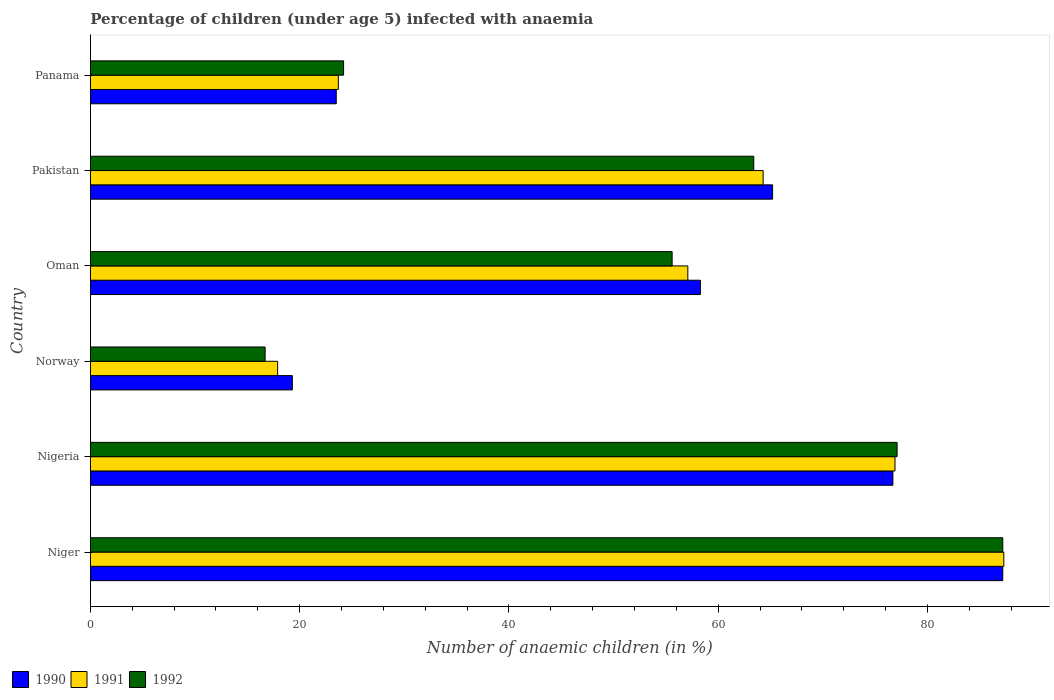How many different coloured bars are there?
Offer a terse response. 3. Are the number of bars per tick equal to the number of legend labels?
Your answer should be very brief. Yes. Are the number of bars on each tick of the Y-axis equal?
Ensure brevity in your answer.  Yes. How many bars are there on the 4th tick from the bottom?
Offer a very short reply. 3. What is the label of the 3rd group of bars from the top?
Keep it short and to the point. Oman. In how many cases, is the number of bars for a given country not equal to the number of legend labels?
Keep it short and to the point. 0. What is the percentage of children infected with anaemia in in 1990 in Norway?
Offer a terse response. 19.3. Across all countries, what is the maximum percentage of children infected with anaemia in in 1992?
Your answer should be compact. 87.2. Across all countries, what is the minimum percentage of children infected with anaemia in in 1992?
Give a very brief answer. 16.7. In which country was the percentage of children infected with anaemia in in 1991 maximum?
Keep it short and to the point. Niger. What is the total percentage of children infected with anaemia in in 1992 in the graph?
Offer a terse response. 324.2. What is the difference between the percentage of children infected with anaemia in in 1991 in Nigeria and that in Norway?
Your answer should be very brief. 59. What is the difference between the percentage of children infected with anaemia in in 1990 in Panama and the percentage of children infected with anaemia in in 1992 in Niger?
Your answer should be compact. -63.7. What is the average percentage of children infected with anaemia in in 1991 per country?
Your answer should be compact. 54.53. What is the difference between the percentage of children infected with anaemia in in 1992 and percentage of children infected with anaemia in in 1991 in Niger?
Make the answer very short. -0.1. What is the ratio of the percentage of children infected with anaemia in in 1990 in Oman to that in Pakistan?
Offer a terse response. 0.89. Is the percentage of children infected with anaemia in in 1991 in Niger less than that in Panama?
Give a very brief answer. No. Is the difference between the percentage of children infected with anaemia in in 1992 in Niger and Oman greater than the difference between the percentage of children infected with anaemia in in 1991 in Niger and Oman?
Offer a very short reply. Yes. What is the difference between the highest and the lowest percentage of children infected with anaemia in in 1990?
Ensure brevity in your answer.  67.9. In how many countries, is the percentage of children infected with anaemia in in 1990 greater than the average percentage of children infected with anaemia in in 1990 taken over all countries?
Offer a very short reply. 4. Is the sum of the percentage of children infected with anaemia in in 1990 in Nigeria and Panama greater than the maximum percentage of children infected with anaemia in in 1992 across all countries?
Provide a succinct answer. Yes. What does the 1st bar from the top in Oman represents?
Offer a terse response. 1992. Is it the case that in every country, the sum of the percentage of children infected with anaemia in in 1992 and percentage of children infected with anaemia in in 1990 is greater than the percentage of children infected with anaemia in in 1991?
Provide a succinct answer. Yes. How many bars are there?
Keep it short and to the point. 18. Are all the bars in the graph horizontal?
Provide a short and direct response. Yes. How many legend labels are there?
Make the answer very short. 3. What is the title of the graph?
Provide a succinct answer. Percentage of children (under age 5) infected with anaemia. Does "1977" appear as one of the legend labels in the graph?
Make the answer very short. No. What is the label or title of the X-axis?
Offer a very short reply. Number of anaemic children (in %). What is the label or title of the Y-axis?
Keep it short and to the point. Country. What is the Number of anaemic children (in %) in 1990 in Niger?
Offer a very short reply. 87.2. What is the Number of anaemic children (in %) in 1991 in Niger?
Make the answer very short. 87.3. What is the Number of anaemic children (in %) of 1992 in Niger?
Your answer should be compact. 87.2. What is the Number of anaemic children (in %) of 1990 in Nigeria?
Offer a terse response. 76.7. What is the Number of anaemic children (in %) of 1991 in Nigeria?
Offer a terse response. 76.9. What is the Number of anaemic children (in %) of 1992 in Nigeria?
Keep it short and to the point. 77.1. What is the Number of anaemic children (in %) in 1990 in Norway?
Ensure brevity in your answer.  19.3. What is the Number of anaemic children (in %) of 1992 in Norway?
Offer a terse response. 16.7. What is the Number of anaemic children (in %) of 1990 in Oman?
Your answer should be compact. 58.3. What is the Number of anaemic children (in %) in 1991 in Oman?
Provide a short and direct response. 57.1. What is the Number of anaemic children (in %) in 1992 in Oman?
Make the answer very short. 55.6. What is the Number of anaemic children (in %) in 1990 in Pakistan?
Offer a terse response. 65.2. What is the Number of anaemic children (in %) in 1991 in Pakistan?
Your answer should be compact. 64.3. What is the Number of anaemic children (in %) in 1992 in Pakistan?
Keep it short and to the point. 63.4. What is the Number of anaemic children (in %) of 1990 in Panama?
Your answer should be very brief. 23.5. What is the Number of anaemic children (in %) in 1991 in Panama?
Provide a succinct answer. 23.7. What is the Number of anaemic children (in %) in 1992 in Panama?
Offer a very short reply. 24.2. Across all countries, what is the maximum Number of anaemic children (in %) in 1990?
Provide a short and direct response. 87.2. Across all countries, what is the maximum Number of anaemic children (in %) of 1991?
Your answer should be compact. 87.3. Across all countries, what is the maximum Number of anaemic children (in %) in 1992?
Provide a short and direct response. 87.2. Across all countries, what is the minimum Number of anaemic children (in %) in 1990?
Provide a succinct answer. 19.3. Across all countries, what is the minimum Number of anaemic children (in %) of 1991?
Provide a succinct answer. 17.9. What is the total Number of anaemic children (in %) of 1990 in the graph?
Provide a short and direct response. 330.2. What is the total Number of anaemic children (in %) of 1991 in the graph?
Provide a succinct answer. 327.2. What is the total Number of anaemic children (in %) of 1992 in the graph?
Keep it short and to the point. 324.2. What is the difference between the Number of anaemic children (in %) of 1990 in Niger and that in Nigeria?
Offer a very short reply. 10.5. What is the difference between the Number of anaemic children (in %) in 1991 in Niger and that in Nigeria?
Offer a very short reply. 10.4. What is the difference between the Number of anaemic children (in %) in 1992 in Niger and that in Nigeria?
Offer a very short reply. 10.1. What is the difference between the Number of anaemic children (in %) of 1990 in Niger and that in Norway?
Give a very brief answer. 67.9. What is the difference between the Number of anaemic children (in %) of 1991 in Niger and that in Norway?
Your answer should be very brief. 69.4. What is the difference between the Number of anaemic children (in %) of 1992 in Niger and that in Norway?
Your answer should be very brief. 70.5. What is the difference between the Number of anaemic children (in %) of 1990 in Niger and that in Oman?
Your answer should be compact. 28.9. What is the difference between the Number of anaemic children (in %) in 1991 in Niger and that in Oman?
Offer a terse response. 30.2. What is the difference between the Number of anaemic children (in %) of 1992 in Niger and that in Oman?
Your answer should be very brief. 31.6. What is the difference between the Number of anaemic children (in %) in 1990 in Niger and that in Pakistan?
Give a very brief answer. 22. What is the difference between the Number of anaemic children (in %) in 1992 in Niger and that in Pakistan?
Make the answer very short. 23.8. What is the difference between the Number of anaemic children (in %) of 1990 in Niger and that in Panama?
Offer a terse response. 63.7. What is the difference between the Number of anaemic children (in %) of 1991 in Niger and that in Panama?
Your response must be concise. 63.6. What is the difference between the Number of anaemic children (in %) in 1992 in Niger and that in Panama?
Make the answer very short. 63. What is the difference between the Number of anaemic children (in %) of 1990 in Nigeria and that in Norway?
Your answer should be compact. 57.4. What is the difference between the Number of anaemic children (in %) of 1992 in Nigeria and that in Norway?
Provide a succinct answer. 60.4. What is the difference between the Number of anaemic children (in %) in 1991 in Nigeria and that in Oman?
Keep it short and to the point. 19.8. What is the difference between the Number of anaemic children (in %) in 1990 in Nigeria and that in Pakistan?
Provide a succinct answer. 11.5. What is the difference between the Number of anaemic children (in %) of 1992 in Nigeria and that in Pakistan?
Your answer should be compact. 13.7. What is the difference between the Number of anaemic children (in %) in 1990 in Nigeria and that in Panama?
Ensure brevity in your answer.  53.2. What is the difference between the Number of anaemic children (in %) of 1991 in Nigeria and that in Panama?
Your answer should be very brief. 53.2. What is the difference between the Number of anaemic children (in %) of 1992 in Nigeria and that in Panama?
Offer a very short reply. 52.9. What is the difference between the Number of anaemic children (in %) of 1990 in Norway and that in Oman?
Your answer should be compact. -39. What is the difference between the Number of anaemic children (in %) of 1991 in Norway and that in Oman?
Offer a terse response. -39.2. What is the difference between the Number of anaemic children (in %) in 1992 in Norway and that in Oman?
Make the answer very short. -38.9. What is the difference between the Number of anaemic children (in %) in 1990 in Norway and that in Pakistan?
Make the answer very short. -45.9. What is the difference between the Number of anaemic children (in %) in 1991 in Norway and that in Pakistan?
Your answer should be compact. -46.4. What is the difference between the Number of anaemic children (in %) of 1992 in Norway and that in Pakistan?
Ensure brevity in your answer.  -46.7. What is the difference between the Number of anaemic children (in %) in 1990 in Norway and that in Panama?
Offer a terse response. -4.2. What is the difference between the Number of anaemic children (in %) of 1991 in Norway and that in Panama?
Provide a short and direct response. -5.8. What is the difference between the Number of anaemic children (in %) of 1992 in Norway and that in Panama?
Ensure brevity in your answer.  -7.5. What is the difference between the Number of anaemic children (in %) of 1991 in Oman and that in Pakistan?
Give a very brief answer. -7.2. What is the difference between the Number of anaemic children (in %) in 1992 in Oman and that in Pakistan?
Your answer should be very brief. -7.8. What is the difference between the Number of anaemic children (in %) of 1990 in Oman and that in Panama?
Offer a very short reply. 34.8. What is the difference between the Number of anaemic children (in %) of 1991 in Oman and that in Panama?
Provide a succinct answer. 33.4. What is the difference between the Number of anaemic children (in %) in 1992 in Oman and that in Panama?
Your answer should be very brief. 31.4. What is the difference between the Number of anaemic children (in %) of 1990 in Pakistan and that in Panama?
Offer a terse response. 41.7. What is the difference between the Number of anaemic children (in %) of 1991 in Pakistan and that in Panama?
Your answer should be very brief. 40.6. What is the difference between the Number of anaemic children (in %) in 1992 in Pakistan and that in Panama?
Make the answer very short. 39.2. What is the difference between the Number of anaemic children (in %) of 1990 in Niger and the Number of anaemic children (in %) of 1991 in Nigeria?
Your answer should be compact. 10.3. What is the difference between the Number of anaemic children (in %) in 1991 in Niger and the Number of anaemic children (in %) in 1992 in Nigeria?
Keep it short and to the point. 10.2. What is the difference between the Number of anaemic children (in %) in 1990 in Niger and the Number of anaemic children (in %) in 1991 in Norway?
Offer a very short reply. 69.3. What is the difference between the Number of anaemic children (in %) in 1990 in Niger and the Number of anaemic children (in %) in 1992 in Norway?
Offer a very short reply. 70.5. What is the difference between the Number of anaemic children (in %) of 1991 in Niger and the Number of anaemic children (in %) of 1992 in Norway?
Ensure brevity in your answer.  70.6. What is the difference between the Number of anaemic children (in %) in 1990 in Niger and the Number of anaemic children (in %) in 1991 in Oman?
Make the answer very short. 30.1. What is the difference between the Number of anaemic children (in %) of 1990 in Niger and the Number of anaemic children (in %) of 1992 in Oman?
Provide a succinct answer. 31.6. What is the difference between the Number of anaemic children (in %) of 1991 in Niger and the Number of anaemic children (in %) of 1992 in Oman?
Offer a very short reply. 31.7. What is the difference between the Number of anaemic children (in %) in 1990 in Niger and the Number of anaemic children (in %) in 1991 in Pakistan?
Ensure brevity in your answer.  22.9. What is the difference between the Number of anaemic children (in %) in 1990 in Niger and the Number of anaemic children (in %) in 1992 in Pakistan?
Keep it short and to the point. 23.8. What is the difference between the Number of anaemic children (in %) in 1991 in Niger and the Number of anaemic children (in %) in 1992 in Pakistan?
Your response must be concise. 23.9. What is the difference between the Number of anaemic children (in %) of 1990 in Niger and the Number of anaemic children (in %) of 1991 in Panama?
Keep it short and to the point. 63.5. What is the difference between the Number of anaemic children (in %) in 1991 in Niger and the Number of anaemic children (in %) in 1992 in Panama?
Ensure brevity in your answer.  63.1. What is the difference between the Number of anaemic children (in %) of 1990 in Nigeria and the Number of anaemic children (in %) of 1991 in Norway?
Keep it short and to the point. 58.8. What is the difference between the Number of anaemic children (in %) in 1990 in Nigeria and the Number of anaemic children (in %) in 1992 in Norway?
Your answer should be compact. 60. What is the difference between the Number of anaemic children (in %) of 1991 in Nigeria and the Number of anaemic children (in %) of 1992 in Norway?
Provide a succinct answer. 60.2. What is the difference between the Number of anaemic children (in %) in 1990 in Nigeria and the Number of anaemic children (in %) in 1991 in Oman?
Your answer should be compact. 19.6. What is the difference between the Number of anaemic children (in %) of 1990 in Nigeria and the Number of anaemic children (in %) of 1992 in Oman?
Keep it short and to the point. 21.1. What is the difference between the Number of anaemic children (in %) of 1991 in Nigeria and the Number of anaemic children (in %) of 1992 in Oman?
Provide a succinct answer. 21.3. What is the difference between the Number of anaemic children (in %) in 1990 in Nigeria and the Number of anaemic children (in %) in 1992 in Pakistan?
Ensure brevity in your answer.  13.3. What is the difference between the Number of anaemic children (in %) in 1991 in Nigeria and the Number of anaemic children (in %) in 1992 in Pakistan?
Give a very brief answer. 13.5. What is the difference between the Number of anaemic children (in %) in 1990 in Nigeria and the Number of anaemic children (in %) in 1992 in Panama?
Offer a very short reply. 52.5. What is the difference between the Number of anaemic children (in %) in 1991 in Nigeria and the Number of anaemic children (in %) in 1992 in Panama?
Keep it short and to the point. 52.7. What is the difference between the Number of anaemic children (in %) in 1990 in Norway and the Number of anaemic children (in %) in 1991 in Oman?
Give a very brief answer. -37.8. What is the difference between the Number of anaemic children (in %) in 1990 in Norway and the Number of anaemic children (in %) in 1992 in Oman?
Provide a short and direct response. -36.3. What is the difference between the Number of anaemic children (in %) of 1991 in Norway and the Number of anaemic children (in %) of 1992 in Oman?
Your response must be concise. -37.7. What is the difference between the Number of anaemic children (in %) in 1990 in Norway and the Number of anaemic children (in %) in 1991 in Pakistan?
Your response must be concise. -45. What is the difference between the Number of anaemic children (in %) in 1990 in Norway and the Number of anaemic children (in %) in 1992 in Pakistan?
Make the answer very short. -44.1. What is the difference between the Number of anaemic children (in %) in 1991 in Norway and the Number of anaemic children (in %) in 1992 in Pakistan?
Offer a very short reply. -45.5. What is the difference between the Number of anaemic children (in %) in 1990 in Norway and the Number of anaemic children (in %) in 1992 in Panama?
Provide a succinct answer. -4.9. What is the difference between the Number of anaemic children (in %) of 1991 in Norway and the Number of anaemic children (in %) of 1992 in Panama?
Make the answer very short. -6.3. What is the difference between the Number of anaemic children (in %) of 1990 in Oman and the Number of anaemic children (in %) of 1991 in Pakistan?
Your answer should be very brief. -6. What is the difference between the Number of anaemic children (in %) of 1990 in Oman and the Number of anaemic children (in %) of 1992 in Pakistan?
Offer a terse response. -5.1. What is the difference between the Number of anaemic children (in %) in 1990 in Oman and the Number of anaemic children (in %) in 1991 in Panama?
Ensure brevity in your answer.  34.6. What is the difference between the Number of anaemic children (in %) of 1990 in Oman and the Number of anaemic children (in %) of 1992 in Panama?
Make the answer very short. 34.1. What is the difference between the Number of anaemic children (in %) of 1991 in Oman and the Number of anaemic children (in %) of 1992 in Panama?
Your answer should be compact. 32.9. What is the difference between the Number of anaemic children (in %) in 1990 in Pakistan and the Number of anaemic children (in %) in 1991 in Panama?
Make the answer very short. 41.5. What is the difference between the Number of anaemic children (in %) in 1990 in Pakistan and the Number of anaemic children (in %) in 1992 in Panama?
Keep it short and to the point. 41. What is the difference between the Number of anaemic children (in %) in 1991 in Pakistan and the Number of anaemic children (in %) in 1992 in Panama?
Your answer should be very brief. 40.1. What is the average Number of anaemic children (in %) in 1990 per country?
Make the answer very short. 55.03. What is the average Number of anaemic children (in %) in 1991 per country?
Offer a terse response. 54.53. What is the average Number of anaemic children (in %) of 1992 per country?
Keep it short and to the point. 54.03. What is the difference between the Number of anaemic children (in %) in 1990 and Number of anaemic children (in %) in 1991 in Nigeria?
Your response must be concise. -0.2. What is the difference between the Number of anaemic children (in %) in 1990 and Number of anaemic children (in %) in 1992 in Nigeria?
Your answer should be very brief. -0.4. What is the difference between the Number of anaemic children (in %) in 1991 and Number of anaemic children (in %) in 1992 in Nigeria?
Your answer should be very brief. -0.2. What is the difference between the Number of anaemic children (in %) in 1990 and Number of anaemic children (in %) in 1991 in Norway?
Your response must be concise. 1.4. What is the difference between the Number of anaemic children (in %) in 1990 and Number of anaemic children (in %) in 1992 in Norway?
Give a very brief answer. 2.6. What is the difference between the Number of anaemic children (in %) of 1990 and Number of anaemic children (in %) of 1991 in Oman?
Make the answer very short. 1.2. What is the difference between the Number of anaemic children (in %) of 1990 and Number of anaemic children (in %) of 1992 in Oman?
Provide a short and direct response. 2.7. What is the difference between the Number of anaemic children (in %) of 1991 and Number of anaemic children (in %) of 1992 in Oman?
Your response must be concise. 1.5. What is the difference between the Number of anaemic children (in %) in 1991 and Number of anaemic children (in %) in 1992 in Pakistan?
Ensure brevity in your answer.  0.9. What is the difference between the Number of anaemic children (in %) of 1990 and Number of anaemic children (in %) of 1991 in Panama?
Offer a terse response. -0.2. What is the ratio of the Number of anaemic children (in %) of 1990 in Niger to that in Nigeria?
Give a very brief answer. 1.14. What is the ratio of the Number of anaemic children (in %) in 1991 in Niger to that in Nigeria?
Your answer should be very brief. 1.14. What is the ratio of the Number of anaemic children (in %) in 1992 in Niger to that in Nigeria?
Give a very brief answer. 1.13. What is the ratio of the Number of anaemic children (in %) of 1990 in Niger to that in Norway?
Provide a succinct answer. 4.52. What is the ratio of the Number of anaemic children (in %) in 1991 in Niger to that in Norway?
Offer a terse response. 4.88. What is the ratio of the Number of anaemic children (in %) in 1992 in Niger to that in Norway?
Your response must be concise. 5.22. What is the ratio of the Number of anaemic children (in %) in 1990 in Niger to that in Oman?
Your answer should be compact. 1.5. What is the ratio of the Number of anaemic children (in %) in 1991 in Niger to that in Oman?
Give a very brief answer. 1.53. What is the ratio of the Number of anaemic children (in %) in 1992 in Niger to that in Oman?
Make the answer very short. 1.57. What is the ratio of the Number of anaemic children (in %) of 1990 in Niger to that in Pakistan?
Ensure brevity in your answer.  1.34. What is the ratio of the Number of anaemic children (in %) of 1991 in Niger to that in Pakistan?
Your response must be concise. 1.36. What is the ratio of the Number of anaemic children (in %) in 1992 in Niger to that in Pakistan?
Provide a short and direct response. 1.38. What is the ratio of the Number of anaemic children (in %) of 1990 in Niger to that in Panama?
Your response must be concise. 3.71. What is the ratio of the Number of anaemic children (in %) of 1991 in Niger to that in Panama?
Make the answer very short. 3.68. What is the ratio of the Number of anaemic children (in %) in 1992 in Niger to that in Panama?
Your answer should be very brief. 3.6. What is the ratio of the Number of anaemic children (in %) in 1990 in Nigeria to that in Norway?
Provide a succinct answer. 3.97. What is the ratio of the Number of anaemic children (in %) in 1991 in Nigeria to that in Norway?
Provide a succinct answer. 4.3. What is the ratio of the Number of anaemic children (in %) in 1992 in Nigeria to that in Norway?
Provide a succinct answer. 4.62. What is the ratio of the Number of anaemic children (in %) of 1990 in Nigeria to that in Oman?
Ensure brevity in your answer.  1.32. What is the ratio of the Number of anaemic children (in %) of 1991 in Nigeria to that in Oman?
Provide a short and direct response. 1.35. What is the ratio of the Number of anaemic children (in %) in 1992 in Nigeria to that in Oman?
Your response must be concise. 1.39. What is the ratio of the Number of anaemic children (in %) in 1990 in Nigeria to that in Pakistan?
Your response must be concise. 1.18. What is the ratio of the Number of anaemic children (in %) in 1991 in Nigeria to that in Pakistan?
Provide a short and direct response. 1.2. What is the ratio of the Number of anaemic children (in %) in 1992 in Nigeria to that in Pakistan?
Keep it short and to the point. 1.22. What is the ratio of the Number of anaemic children (in %) of 1990 in Nigeria to that in Panama?
Your answer should be very brief. 3.26. What is the ratio of the Number of anaemic children (in %) of 1991 in Nigeria to that in Panama?
Keep it short and to the point. 3.24. What is the ratio of the Number of anaemic children (in %) in 1992 in Nigeria to that in Panama?
Provide a succinct answer. 3.19. What is the ratio of the Number of anaemic children (in %) in 1990 in Norway to that in Oman?
Keep it short and to the point. 0.33. What is the ratio of the Number of anaemic children (in %) in 1991 in Norway to that in Oman?
Offer a terse response. 0.31. What is the ratio of the Number of anaemic children (in %) of 1992 in Norway to that in Oman?
Provide a succinct answer. 0.3. What is the ratio of the Number of anaemic children (in %) of 1990 in Norway to that in Pakistan?
Offer a terse response. 0.3. What is the ratio of the Number of anaemic children (in %) of 1991 in Norway to that in Pakistan?
Give a very brief answer. 0.28. What is the ratio of the Number of anaemic children (in %) in 1992 in Norway to that in Pakistan?
Make the answer very short. 0.26. What is the ratio of the Number of anaemic children (in %) of 1990 in Norway to that in Panama?
Offer a very short reply. 0.82. What is the ratio of the Number of anaemic children (in %) of 1991 in Norway to that in Panama?
Your response must be concise. 0.76. What is the ratio of the Number of anaemic children (in %) in 1992 in Norway to that in Panama?
Your answer should be compact. 0.69. What is the ratio of the Number of anaemic children (in %) of 1990 in Oman to that in Pakistan?
Make the answer very short. 0.89. What is the ratio of the Number of anaemic children (in %) of 1991 in Oman to that in Pakistan?
Your answer should be compact. 0.89. What is the ratio of the Number of anaemic children (in %) of 1992 in Oman to that in Pakistan?
Make the answer very short. 0.88. What is the ratio of the Number of anaemic children (in %) in 1990 in Oman to that in Panama?
Offer a terse response. 2.48. What is the ratio of the Number of anaemic children (in %) in 1991 in Oman to that in Panama?
Your response must be concise. 2.41. What is the ratio of the Number of anaemic children (in %) in 1992 in Oman to that in Panama?
Make the answer very short. 2.3. What is the ratio of the Number of anaemic children (in %) of 1990 in Pakistan to that in Panama?
Offer a very short reply. 2.77. What is the ratio of the Number of anaemic children (in %) of 1991 in Pakistan to that in Panama?
Ensure brevity in your answer.  2.71. What is the ratio of the Number of anaemic children (in %) in 1992 in Pakistan to that in Panama?
Your response must be concise. 2.62. What is the difference between the highest and the lowest Number of anaemic children (in %) in 1990?
Ensure brevity in your answer.  67.9. What is the difference between the highest and the lowest Number of anaemic children (in %) of 1991?
Give a very brief answer. 69.4. What is the difference between the highest and the lowest Number of anaemic children (in %) of 1992?
Make the answer very short. 70.5. 